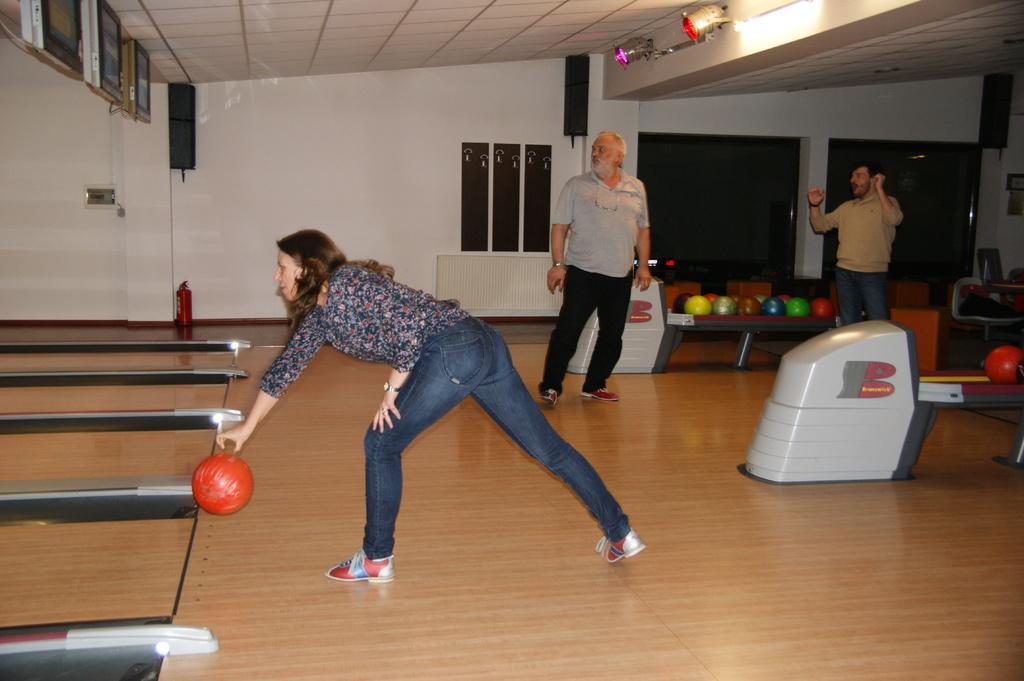In one or two sentences, can you explain what this image depicts? In this image we can a woman is standing on the floor, here is the ball, at back here a man is standing, here is the light, here is the wall, here is the roof. 